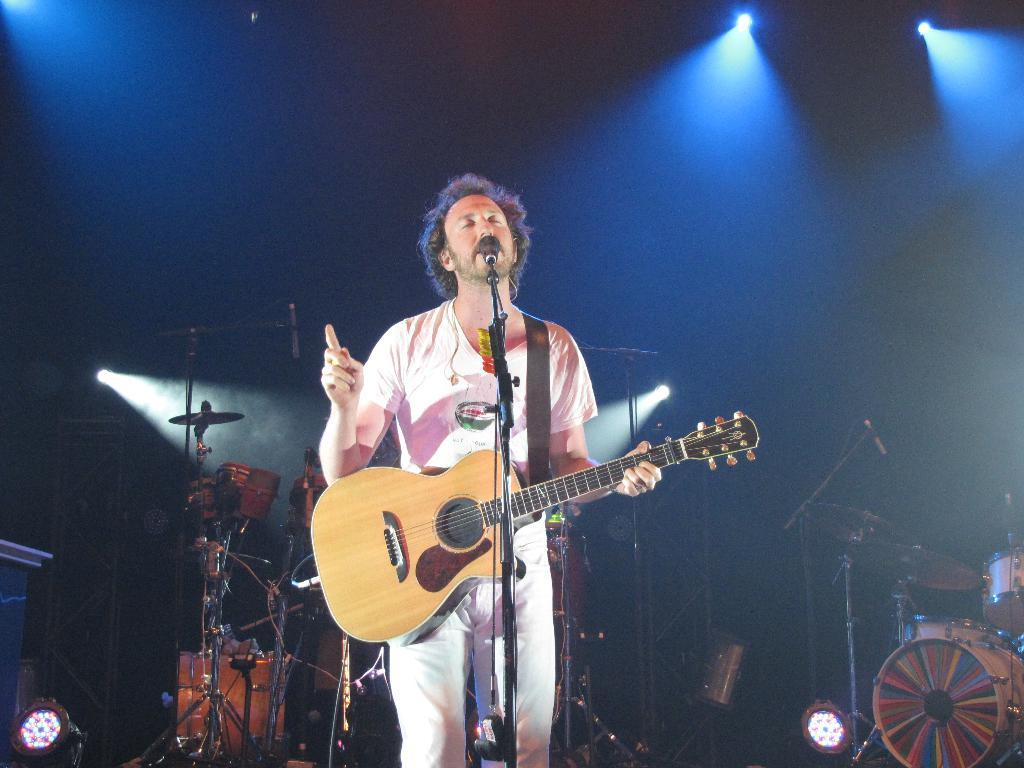What is the man in the center of the image doing? The man is standing in the center of the image and holding a guitar. What object is in front of the man? There is a microphone in front of the man. What can be seen in the background of the image? There is a wall and a light in the background of the image. Are there any other musical instruments visible in the image? Yes, there are musical instruments in the background of the image. What type of frog is sitting on the man's shoulder in the image? There is no frog present in the image; the man is holding a guitar and standing near a microphone and musical instruments. 